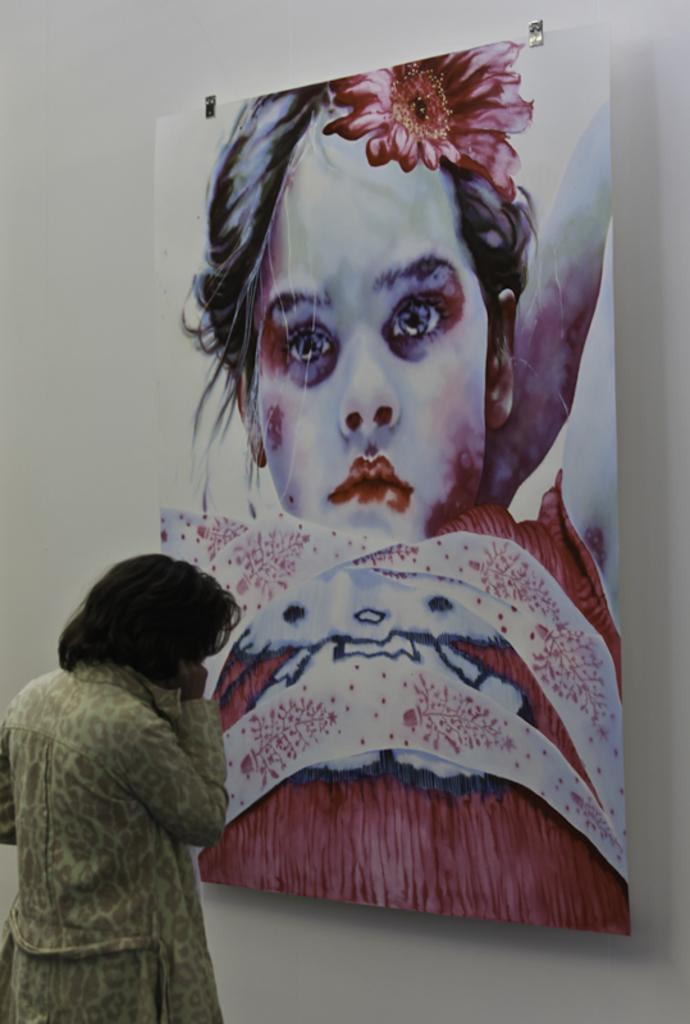Who is present in the image? There is a lady in the image. What can be seen on the wall in the image? There is a painting on the wall in the image. What type of throat condition does the lady have in the image? There is no indication of any throat condition in the image. Can you see any zephyrs in the image? There is no mention of any zephyrs in the image. Is the lady playing basketball in the image? There is no indication of the lady playing basketball in the image. 